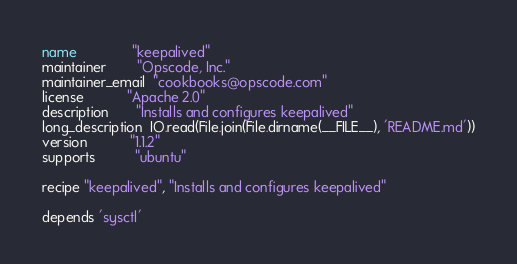<code> <loc_0><loc_0><loc_500><loc_500><_Ruby_>name              "keepalived"
maintainer        "Opscode, Inc."
maintainer_email  "cookbooks@opscode.com"
license           "Apache 2.0"
description       "Installs and configures keepalived"
long_description  IO.read(File.join(File.dirname(__FILE__), 'README.md'))
version           "1.1.2"
supports          "ubuntu"

recipe "keepalived", "Installs and configures keepalived"

depends 'sysctl'</code> 